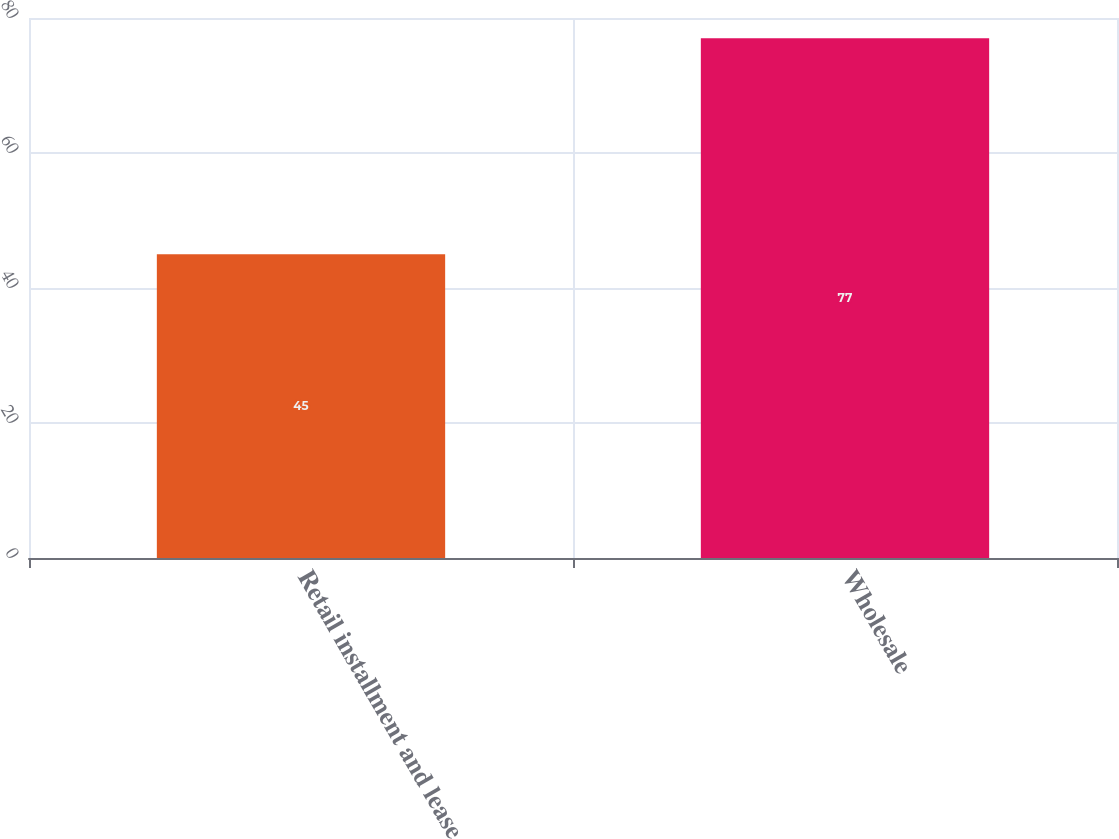Convert chart. <chart><loc_0><loc_0><loc_500><loc_500><bar_chart><fcel>Retail installment and lease<fcel>Wholesale<nl><fcel>45<fcel>77<nl></chart> 